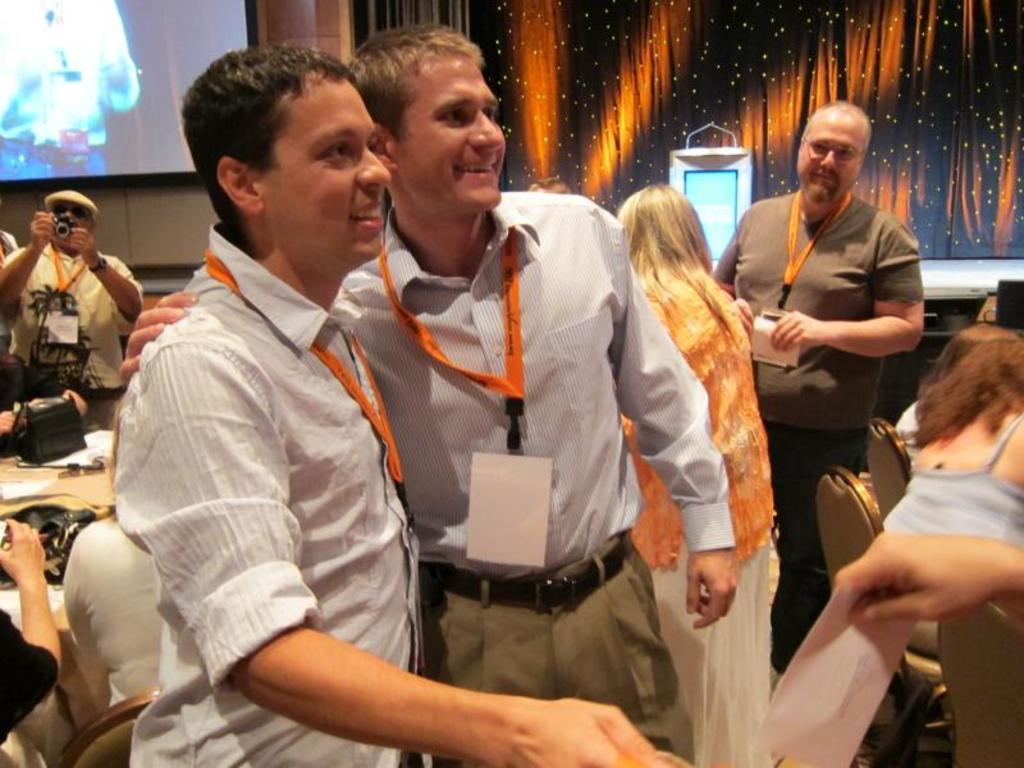Could you give a brief overview of what you see in this image? Front these two people wore id cards and smiling. Background there is a screen. This man is holding a camera. Few people are sitting on chairs. On this table there is a bag and papers.  